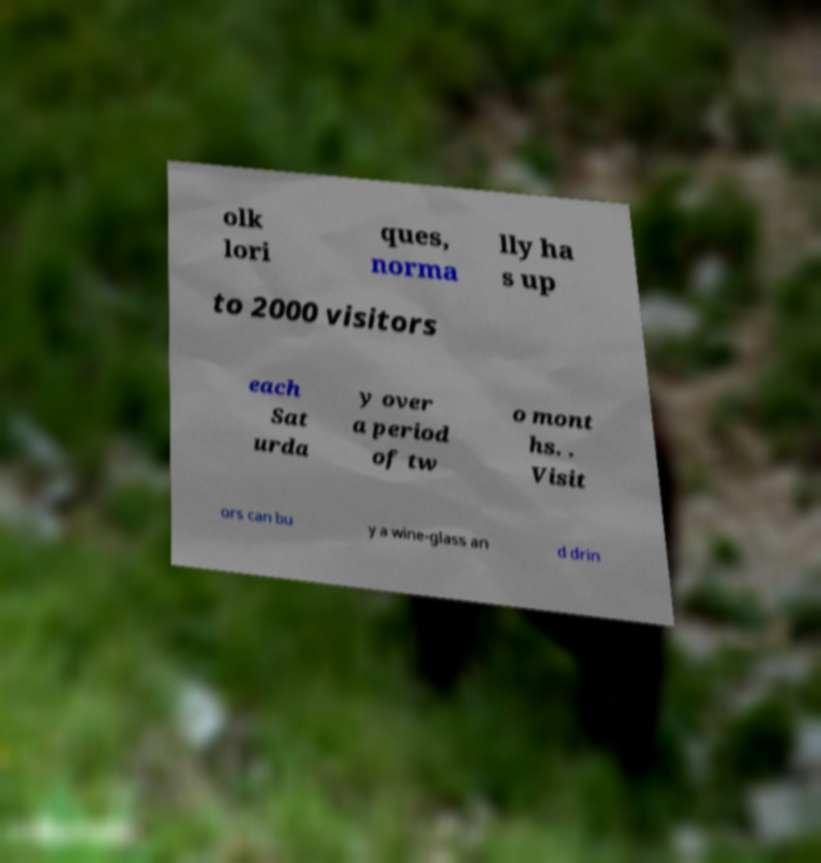Please identify and transcribe the text found in this image. olk lori ques, norma lly ha s up to 2000 visitors each Sat urda y over a period of tw o mont hs. . Visit ors can bu y a wine-glass an d drin 